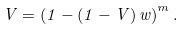Convert formula to latex. <formula><loc_0><loc_0><loc_500><loc_500>V = \left ( 1 - ( 1 - V ) \, w \right ) ^ { m } .</formula> 